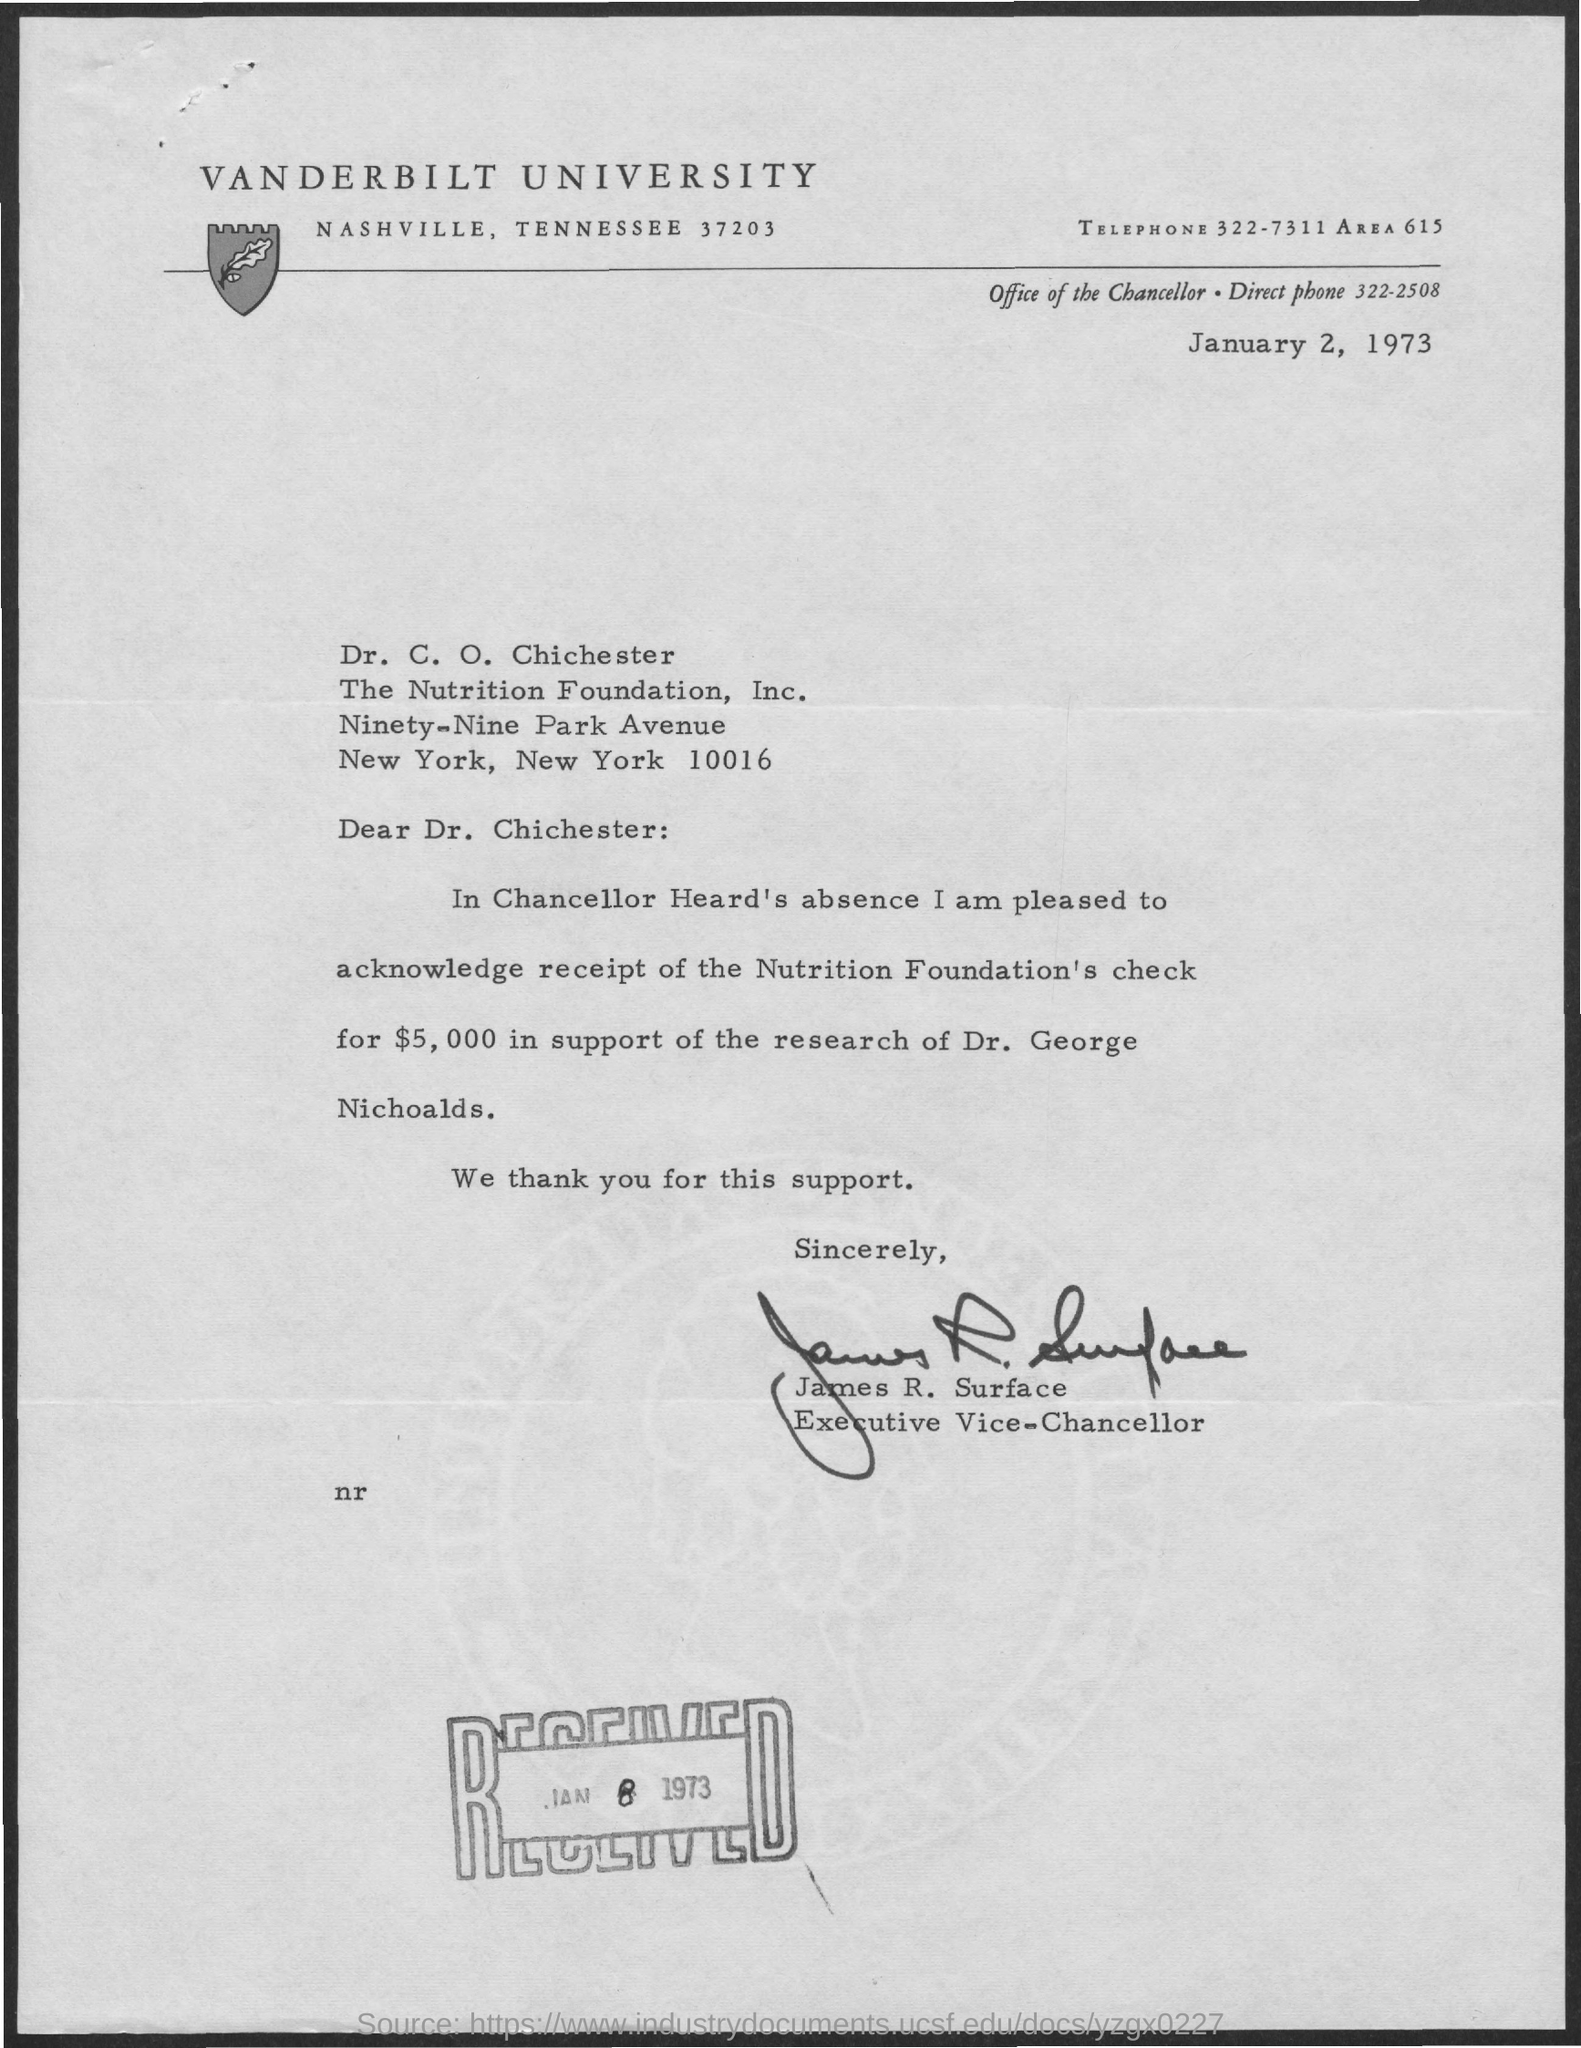What is the name of the university
Give a very brief answer. Vanderbilt University. What is the office of the chancellor direct telephone
Give a very brief answer. 322-2508. Who is the executive vice-chancellor of university
Ensure brevity in your answer.  James R. Surface. What is the date of received
Ensure brevity in your answer.  Jan 8 , 1973. How much is the check amount
Give a very brief answer. $5,000. 